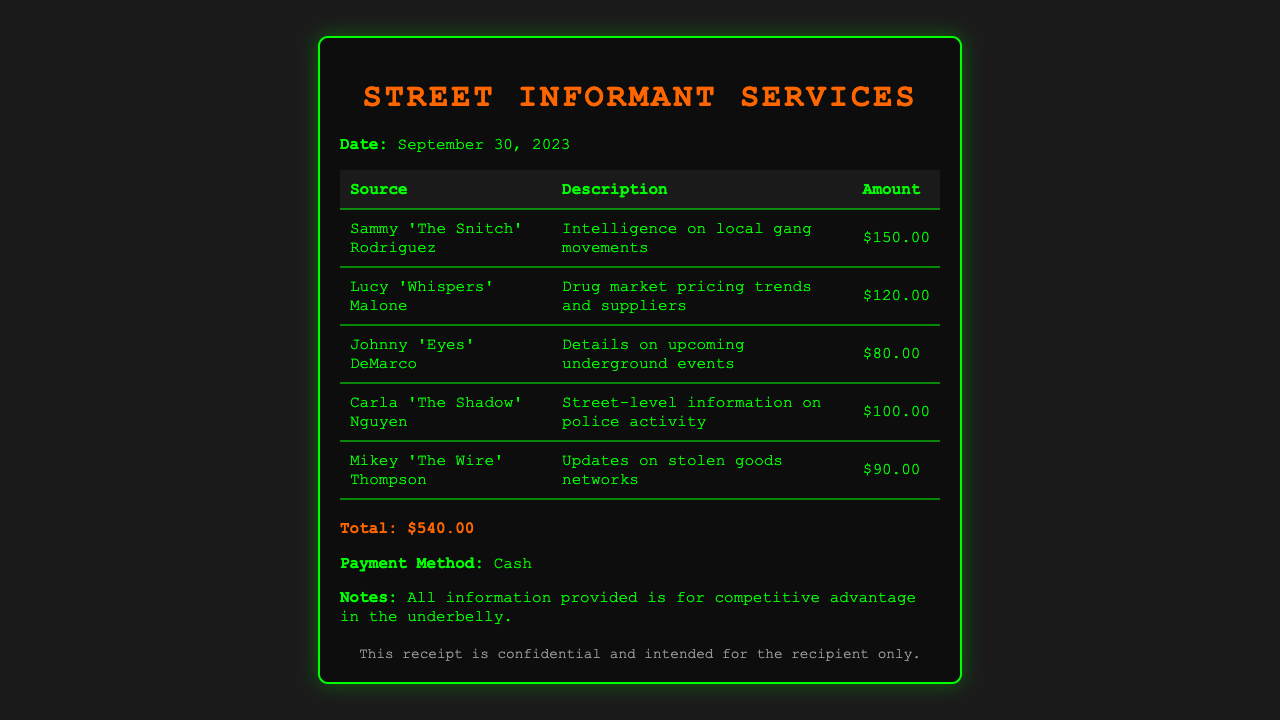What is the total amount charged? The total amount charged is explicitly stated at the bottom of the receipt, summing all itemized charges.
Answer: $540.00 Who provided intelligence on local gang movements? This name appears in the first row of the itemized charges detailing the source of information.
Answer: Sammy 'The Snitch' Rodriguez What was Lucy 'Whispers' Malone's charge? The amount charged by Lucy 'Whispers' Malone appears in her respective row in the table.
Answer: $120.00 What date is on the receipt? The date is specified prominently at the top of the receipt under the date label.
Answer: September 30, 2023 How many sources of information were consulted? The number of sources is determined by counting the rows in the itemized section of the receipt.
Answer: 5 What type of payment was made? This detail is provided near the end of the receipt indicating how the payment was settled.
Answer: Cash What is the description for Mikey 'The Wire' Thompson's charge? The description is listed in the row associated with Mikey 'The Wire' Thompson, detailing the nature of the information provided.
Answer: Updates on stolen goods networks What is the color scheme of the document? The color scheme of the receipt can be inferred from the styling elements described, focusing on text and background colors.
Answer: Green and black Is this receipt confidential? The confidentiality of the receipt is mentioned in the footer area of the document.
Answer: Yes 